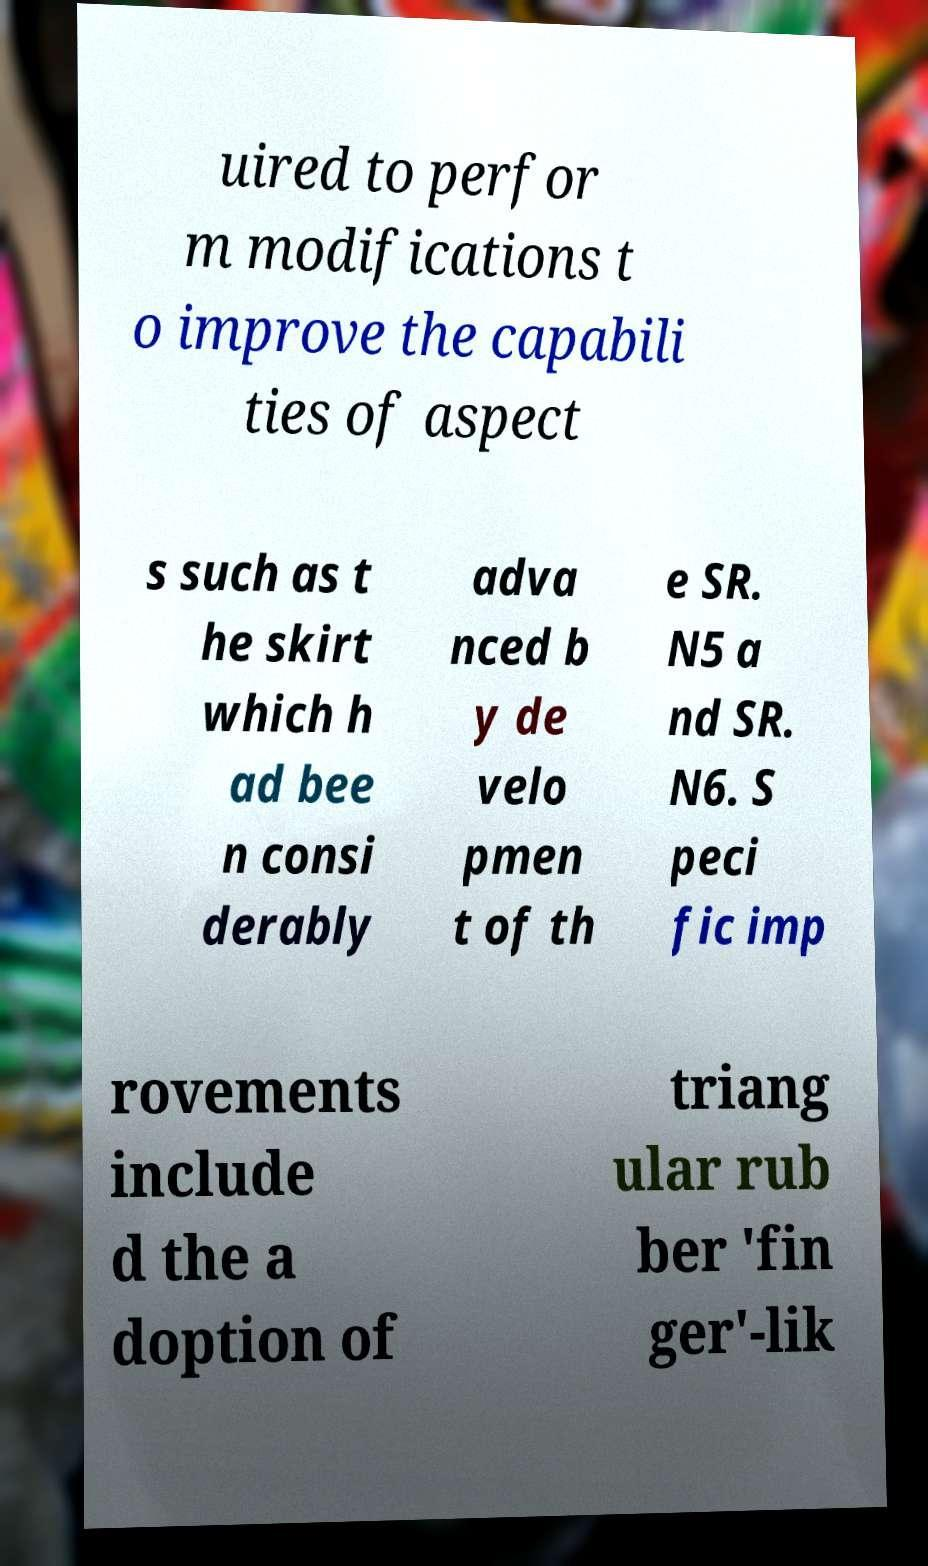Please identify and transcribe the text found in this image. uired to perfor m modifications t o improve the capabili ties of aspect s such as t he skirt which h ad bee n consi derably adva nced b y de velo pmen t of th e SR. N5 a nd SR. N6. S peci fic imp rovements include d the a doption of triang ular rub ber 'fin ger'-lik 